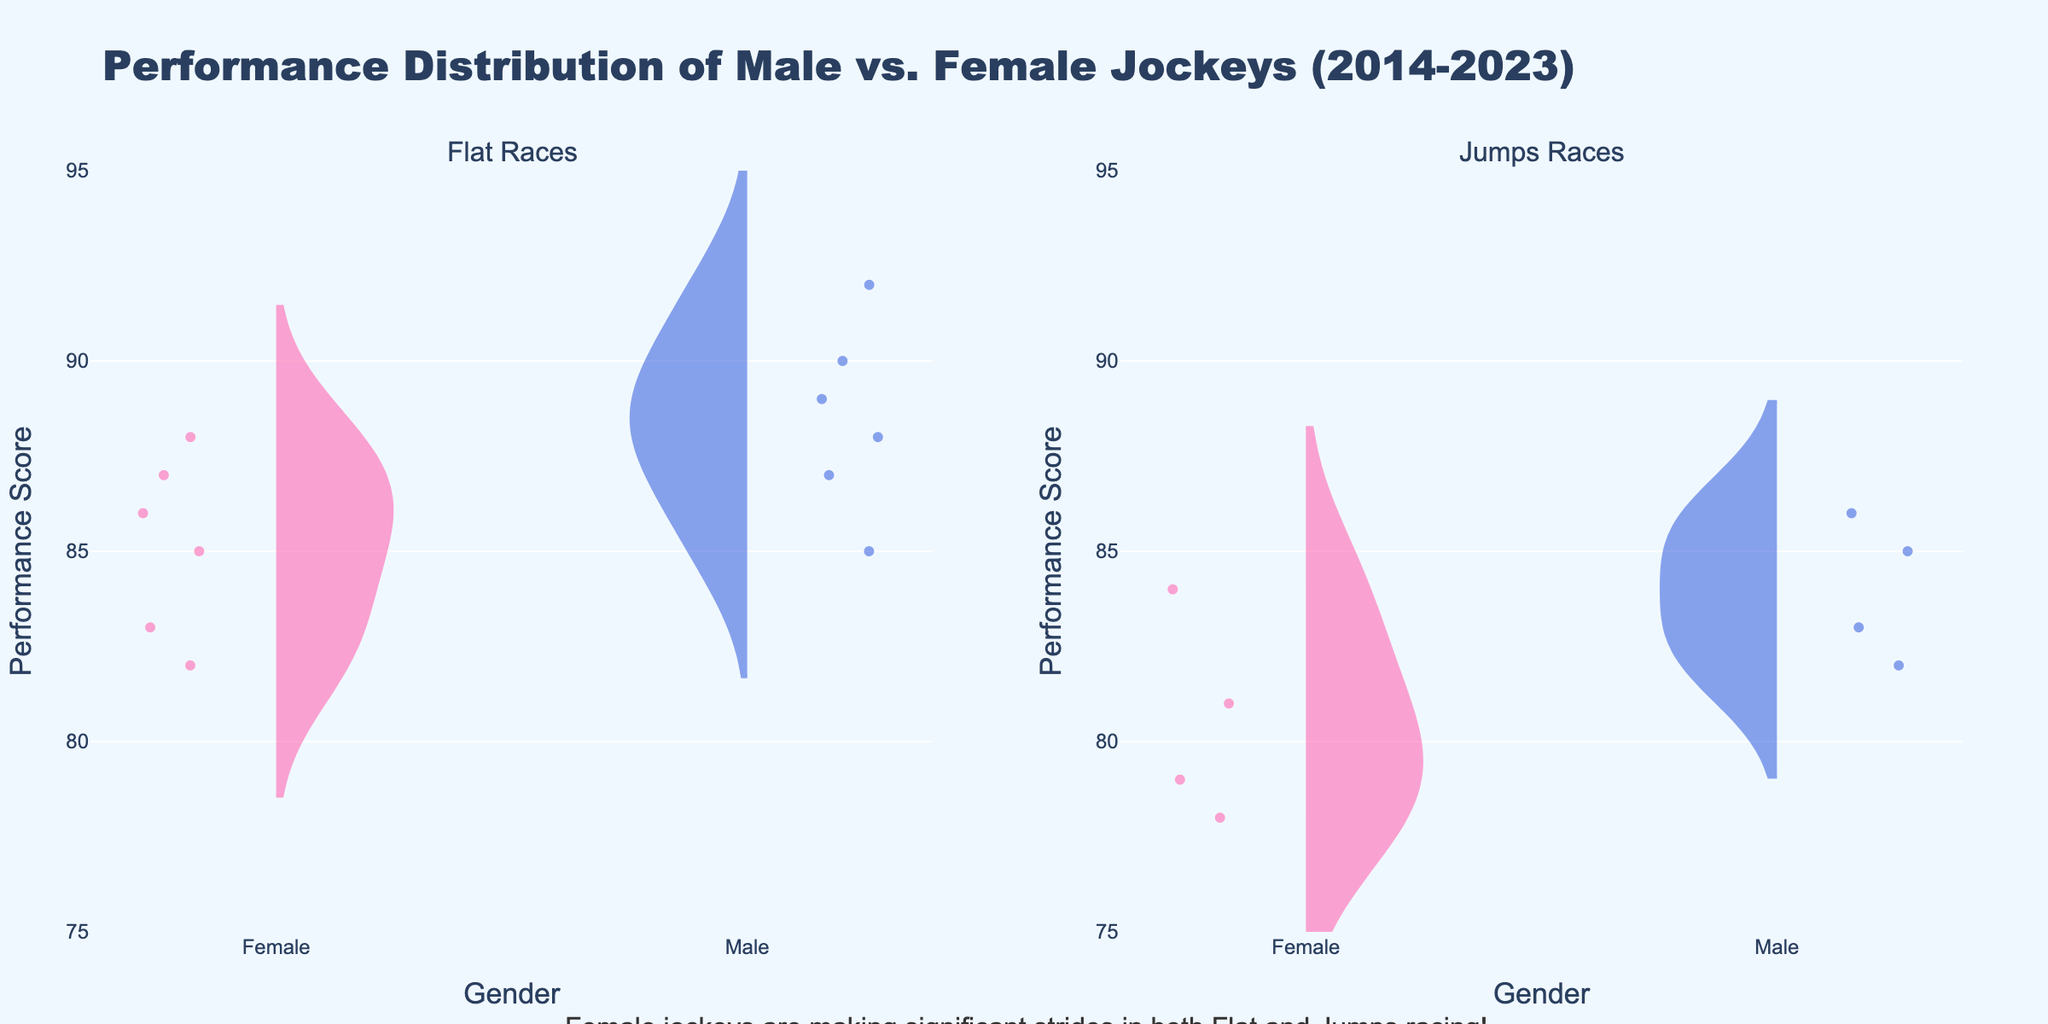What does the title of the figure indicate? The title of the figure indicates the main subject of the visual, which is the Performance Distribution of Male vs. Female Jockeys over the last decade (2014-2023).
Answer: Performance Distribution of Male vs. Female Jockeys (2014-2023) What are the races compared in the figure? The figure compares the performance distributions for Flat Races and Jumps Races, as indicated by the subplot titles.
Answer: Flat Races and Jumps Races What color is used to represent female jockeys in the plot? The color used to represent female jockeys in the plot is a shade of pink.
Answer: Pink What is the general trend of male jockeys’ performance scores in Flat Races? Most of the male jockeys' performance scores in Flat Races appear to be clustered in the higher range, generally between 85 and 92.
Answer: Between 85 and 92 Which gender shows a higher mean performance score in Flat Races based on the figure? Male jockeys show a higher mean performance score in Flat Races as indicated by the mean lines in the corresponding violin plots.
Answer: Male What is the range of performance scores for female jockeys in Jumps Races? The range of performance scores for female jockeys in Jumps Races appears to be between 78 and 85 based on the extent of the violin plot.
Answer: 78 to 85 In which race type do female jockeys show less variability in performance scores? Female jockeys show less variability in performance scores in Flat Races compared to Jumps Races, as the violin plot is more condensed.
Answer: Flat Races Which gender has a more dispersed performance score distribution in Jumps Races? Male jockeys have a more dispersed performance score distribution in Jumps Races, as indicated by the wider spread of the violin plot.
Answer: Male Are there any outliers visible for the performance scores of female jockeys in Flat Races? Yes, there are points outside the main violin plot area indicating the presence of individual data points, which can be considered outliers.
Answer: Yes How do the spreads of scores compare between male and female jockeys in Flat Races? The spread of scores for male jockeys is slightly higher than that for female jockeys in Flat Races, indicating more variability in male performance scores.
Answer: Higher for males 